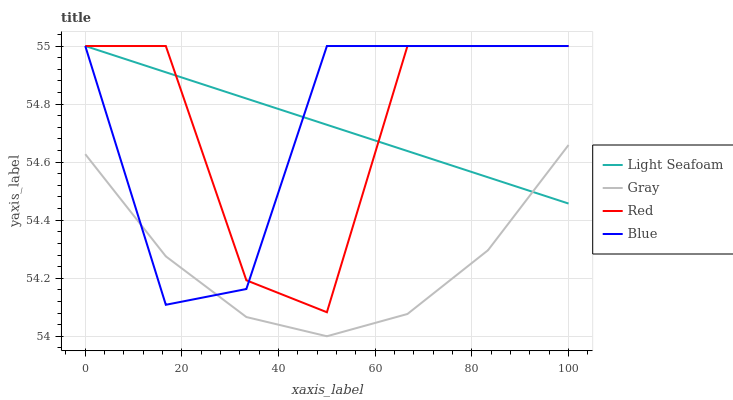Does Gray have the minimum area under the curve?
Answer yes or no. Yes. Does Light Seafoam have the maximum area under the curve?
Answer yes or no. Yes. Does Light Seafoam have the minimum area under the curve?
Answer yes or no. No. Does Gray have the maximum area under the curve?
Answer yes or no. No. Is Light Seafoam the smoothest?
Answer yes or no. Yes. Is Red the roughest?
Answer yes or no. Yes. Is Gray the smoothest?
Answer yes or no. No. Is Gray the roughest?
Answer yes or no. No. Does Gray have the lowest value?
Answer yes or no. Yes. Does Light Seafoam have the lowest value?
Answer yes or no. No. Does Red have the highest value?
Answer yes or no. Yes. Does Gray have the highest value?
Answer yes or no. No. Is Gray less than Red?
Answer yes or no. Yes. Is Red greater than Gray?
Answer yes or no. Yes. Does Blue intersect Gray?
Answer yes or no. Yes. Is Blue less than Gray?
Answer yes or no. No. Is Blue greater than Gray?
Answer yes or no. No. Does Gray intersect Red?
Answer yes or no. No. 